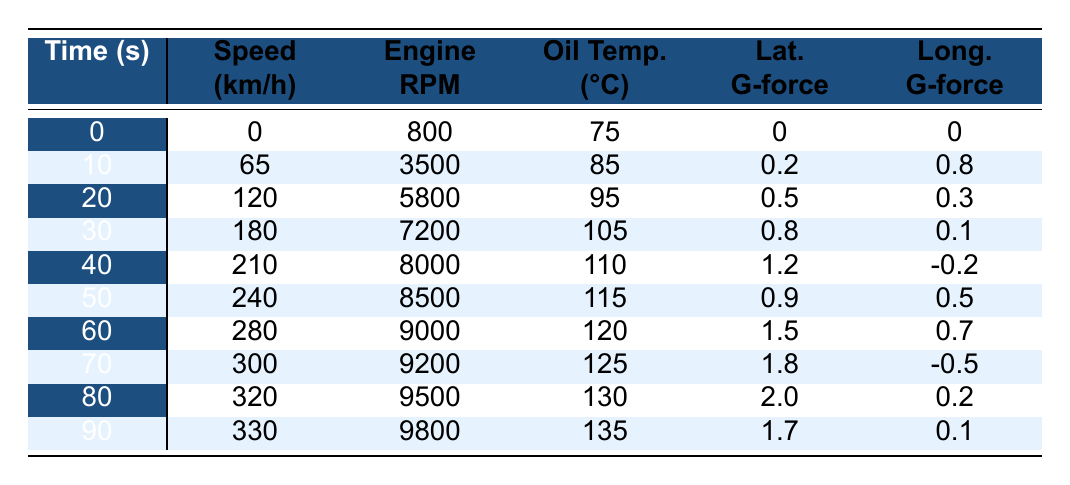What is the speed of the car at 30 seconds? Looking at the table, the speed at the time of 30 seconds is clearly listed as 180 km/h.
Answer: 180 km/h What was the maximum engine RPM recorded? The highest engine RPM in the table is found at 90 seconds, where it reaches 9800 RPM.
Answer: 9800 RPM At what time did the oil temperature first exceed 100°C? By reviewing the oil temperature column, it can be seen that the temperature first exceeds 100°C at 30 seconds.
Answer: 30 seconds What is the average speed of the car from 0 to 90 seconds? The speeds recorded at 0s, 10s, 20s, 30s, 40s, 50s, 60s, 70s, 80s, and 90s are added together: (0 + 65 + 120 + 180 + 210 + 240 + 280 + 300 + 320 + 330) = 1825 km/h. Then, this sum is divided by 10 (the number of data points): 1825 / 10 = 182.5.
Answer: 182.5 km/h Did the tire pressure in the rear-left tire (RL) ever drop below 2.5 bar? By looking at the "Tire Pressure RL" column, all values are 2.4 bar or higher, and at no time does it drop below 2.5 bar.
Answer: No What was the change in brake temperature from 0 to 90 seconds for the front-left tire? The initial temperature at 0 seconds is 100°C and at 90 seconds it is 550°C. The difference is 550 - 100 = 450°C.
Answer: 450°C At what second did the longitudinal G-force reach its maximum value? Reviewing the "Longitudinal G-force" column, the maximum value is +0.8, which occurs at both 10 and 80 seconds.
Answer: 10 seconds and 80 seconds What is the total increase in tire pressure for the front-left tire (FL) from 0 to 90 seconds? The tire pressure starts at 2.3 bar at 0 seconds and rises to 3.2 bar at 90 seconds. The total increase is 3.2 - 2.3 = 0.9 bar.
Answer: 0.9 bar What fuel consumption value was recorded at 50 seconds? According to the table, the fuel consumption at 50 seconds is 28.6 L/100km.
Answer: 28.6 L/100km How many times did the lateral G-force exceed 1.5 during the test? The "Lateral G-force" values are 0, 0.2, 0.5, 0.8, 1.2, 0.9, 1.5, 1.8, 2.0, and 1.7 which shows that it exceeded 1.5 at 70, 80, and 90 seconds, making it 3 times.
Answer: 3 times 